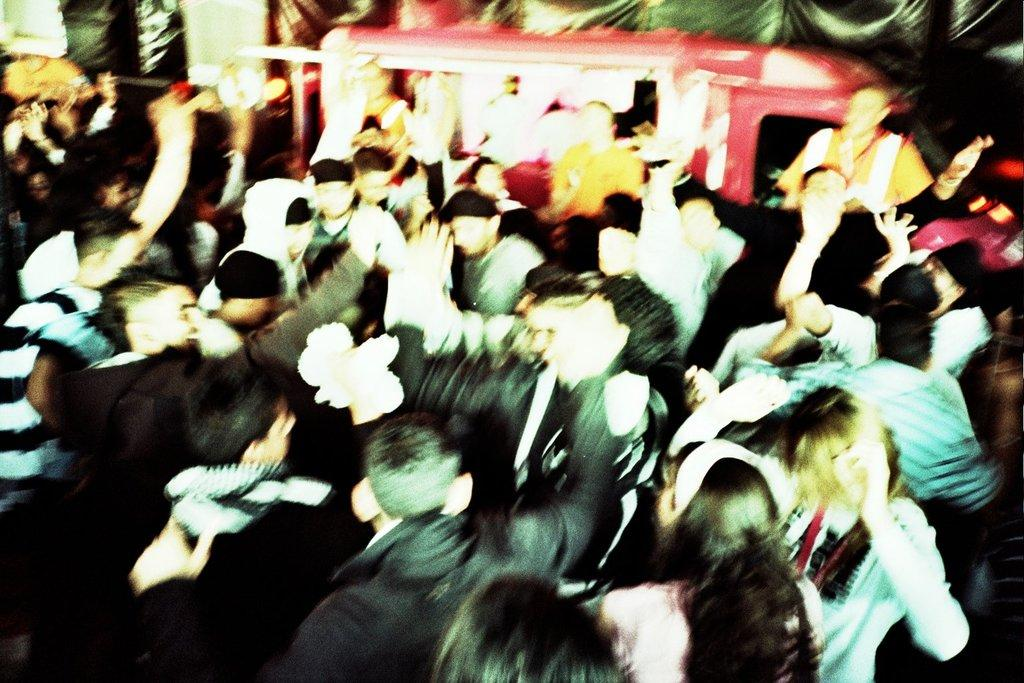What is the main subject of the image? The main subject of the image is a crowd. Can you describe anything in the background of the image? Yes, there is a vehicle in the background of the image. What else can be seen in the image besides the crowd and the vehicle? There is a curtain in the image. What type of reaction can be seen on the spade in the image? There is no spade present in the image, and therefore no reaction can be observed on it. 